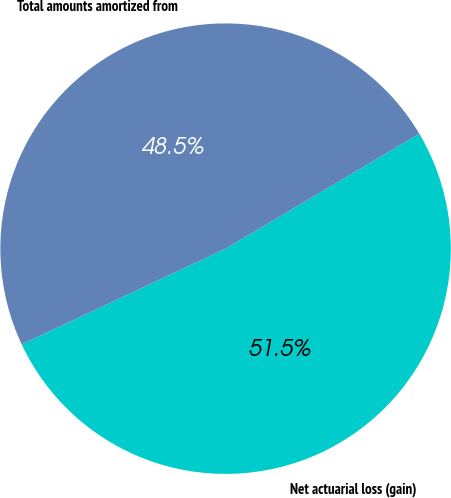<chart> <loc_0><loc_0><loc_500><loc_500><pie_chart><fcel>Net actuarial loss (gain)<fcel>Total amounts amortized from<nl><fcel>51.54%<fcel>48.46%<nl></chart> 